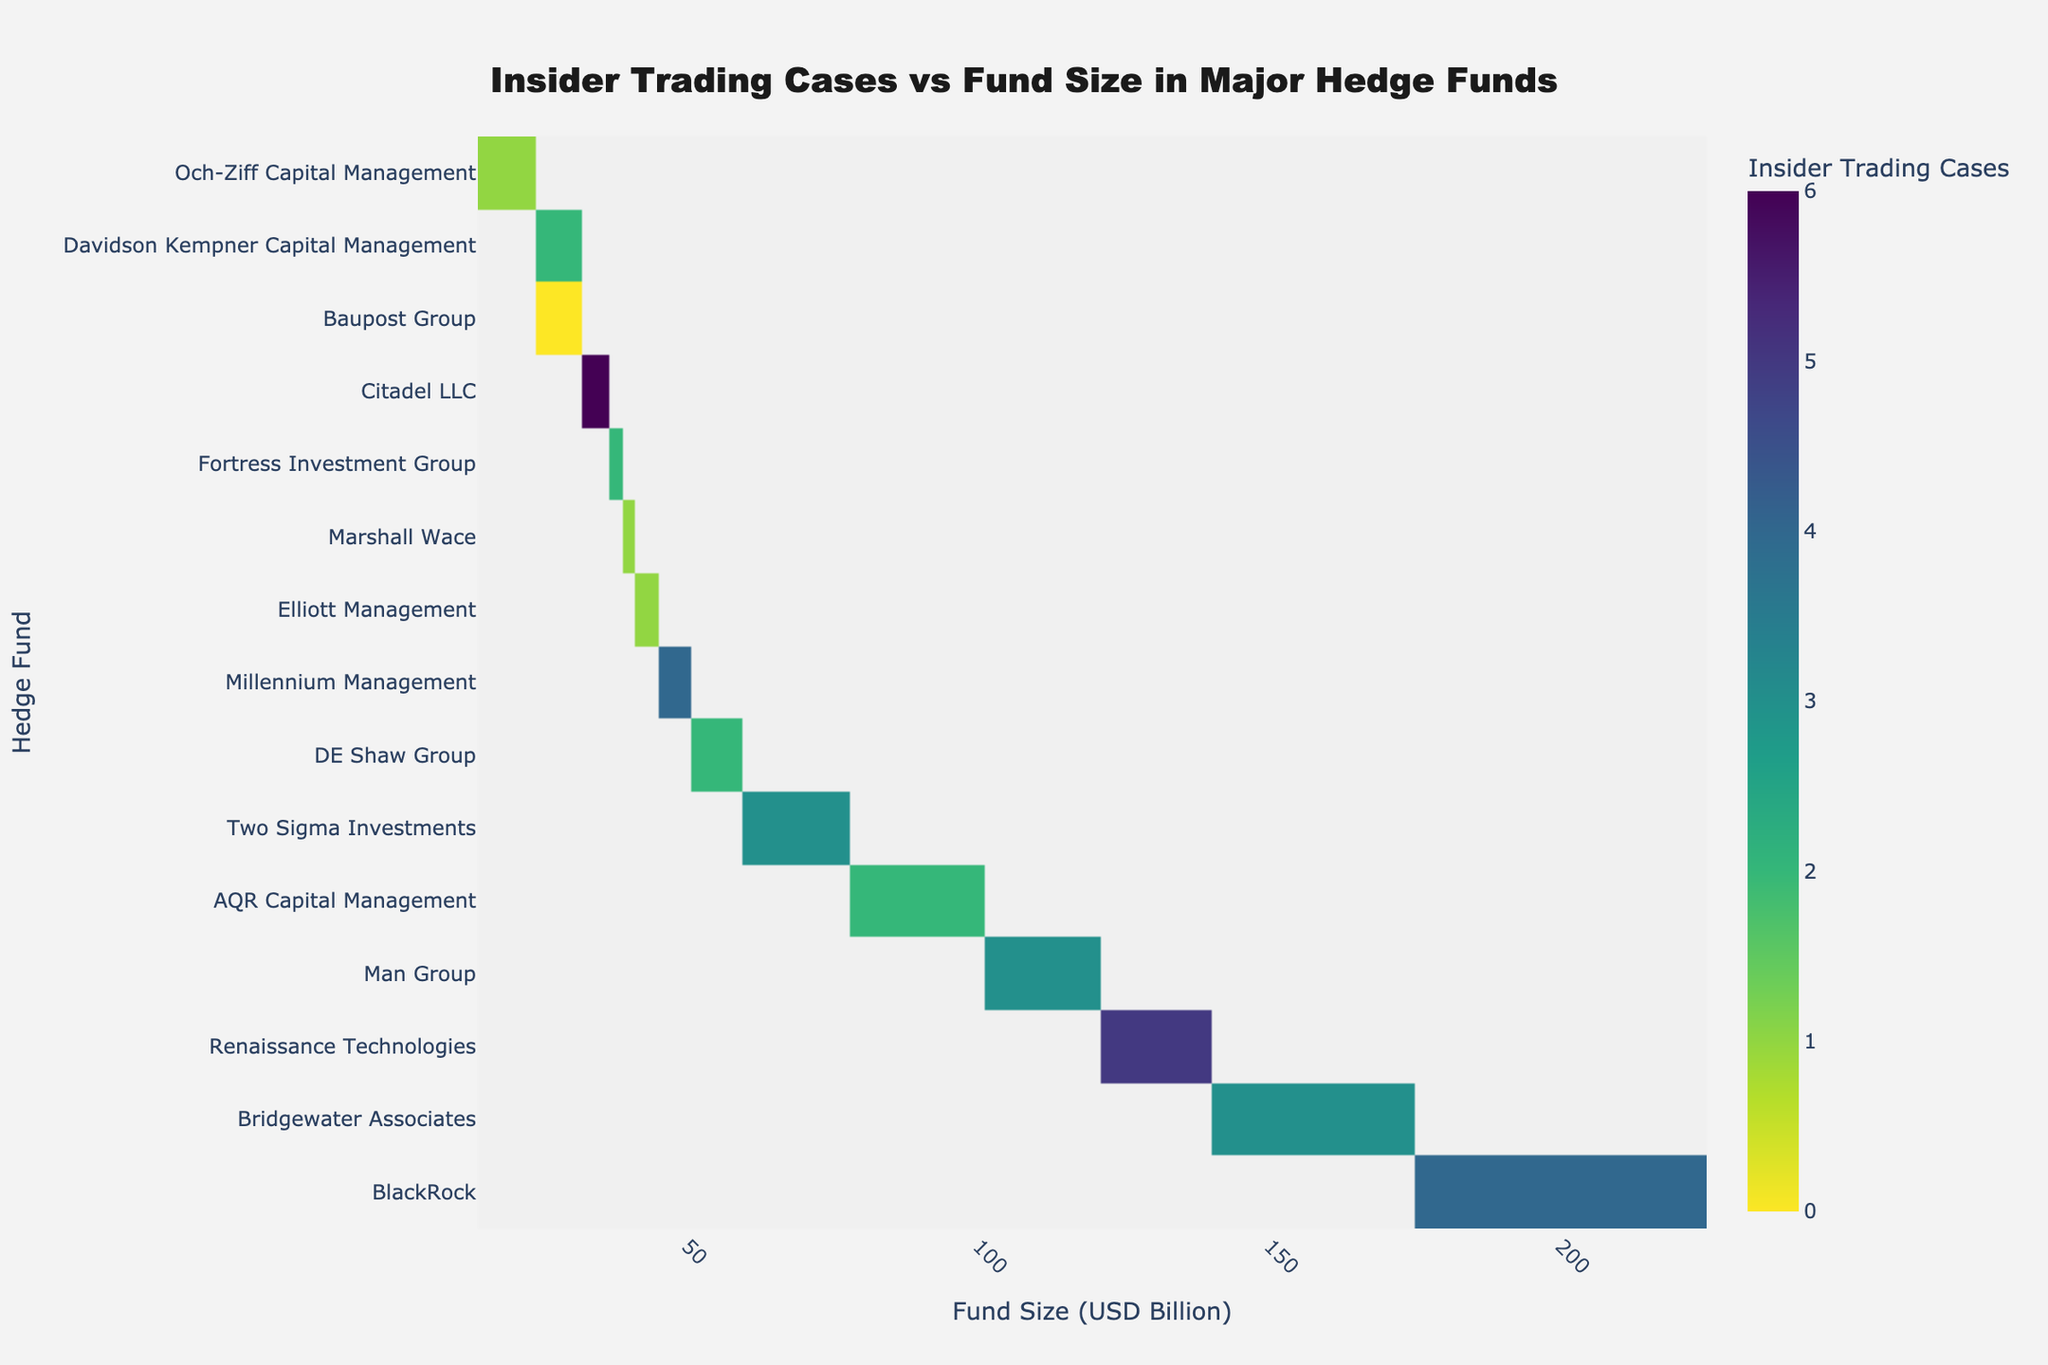What is the title of the heatmap figure? The title of the figure is typically displayed at the top of the plot. By looking at the figure, the title "Insider Trading Cases vs Fund Size in Major Hedge Funds" is visible.
Answer: Insider Trading Cases vs Fund Size in Major Hedge Funds Which hedge fund has the largest fund size? The hedge fund with the largest fund size is usually listed at the top of the y-axis when sorted by fund size. In this case, it is Bridgewater Associates, with a fund size of $150 billion.
Answer: Bridgewater Associates What's the total number of insider trading cases for hedge funds with a fund size greater than $100 billion? By examining the heatmap and summing up the insider trading cases for funds greater than $100 billion (BlackRock, Bridgewater Associates, Renaissance Technologies, Man Group), we get 4 + 3 + 5 + 3 = 15.
Answer: 15 Which hedge fund has the highest number of insider trading cases? Looking at the heatmap, the hedge fund with the darkest color under the "Insider Trading Cases" color scale indicates the highest number of cases. Citadel LLC has the darkest color with 6 cases.
Answer: Citadel LLC How does the number of insider trading cases in Elliott Management compare with that of DE Shaw Group? The heatmap shows the number of insider trading cases by color intensity. Elliott Management has 1 case, while DE Shaw Group has 2 cases. Therefore, DE Shaw Group has more cases than Elliott Management.
Answer: Elliott Management has 1 case, DE Shaw Group has 2 cases What is the fund size range for hedge funds with 3 insider trading cases? By examining the heatmap, the hedge funds with 3 insider trading cases include Bridgewater Associates, Two Sigma Investments, and Man Group. Their fund sizes range from $66 billion (Two Sigma Investments) to $150 billion (Bridgewater Associates).
Answer: $66 billion to $150 billion What is the median fund size of hedge funds that have more than 2 insider trading cases? First, identify the hedge funds with more than 2 cases: Citadel LLC (6), Renaissance Technologies (5), BlackRock (4), Millennium Management (4), Bridgewater Associates (3), Two Sigma Investments (3), Man Group (3). The fund sizes are 35, 130, 200, 48, 150, 66, 112. Sorting these sizes (35, 48, 66, 112, 130, 150, 200) and finding the median value, which is the fourth value in the sorted list, the median is $112 billion.
Answer: $112 billion Compare the insider trading cases between hedge funds with a fund size less than $50 billion and those with a fund size greater than $50 billion? Identify hedge funds with a fund size less than $50 billion: Davidson Kempner Capital Management (2), Marshall Wace (1), Fortress Investment Group (2), Och-Ziff Capital Management (1), Baupost Group (0). Summing up their cases: 2+1+2+1+0=6. For funds greater than $50 billion: DE Shaw Group (2), Two Sigma Investments (3), Millennium Management (4), AQR Capital Management (2), Renaissance Technologies (5), Man Group (3), Bridgewater Associates (3), BlackRock (4). Summing up their cases: 2+3+4+2+5+3+3+4=26. Comparing 6 cases vs 26 cases.
Answer: Less than $50 billion: 6 cases, Greater than $50 billion: 26 cases Which color in the heatmap represents the highest number of insider trading cases? In a heatmap, darker colors typically represent higher values. By checking the color bar legend, the darkest color represents the highest number of insider trading cases.
Answer: Darkest color (usually dark green in Viridis scale) 